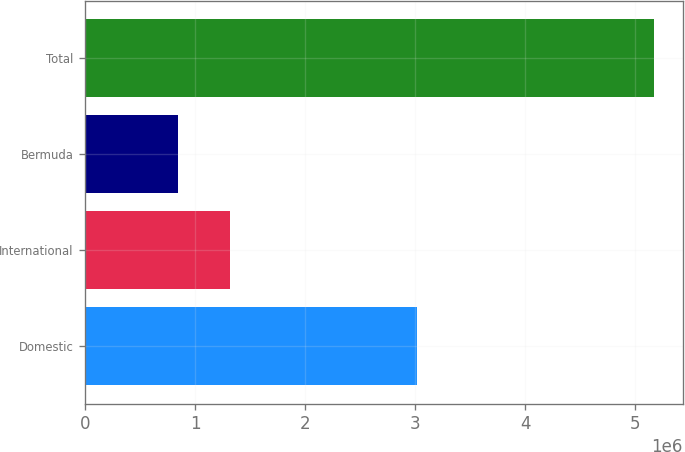<chart> <loc_0><loc_0><loc_500><loc_500><bar_chart><fcel>Domestic<fcel>International<fcel>Bermuda<fcel>Total<nl><fcel>3.01707e+06<fcel>1.3109e+06<fcel>841164<fcel>5.16914e+06<nl></chart> 